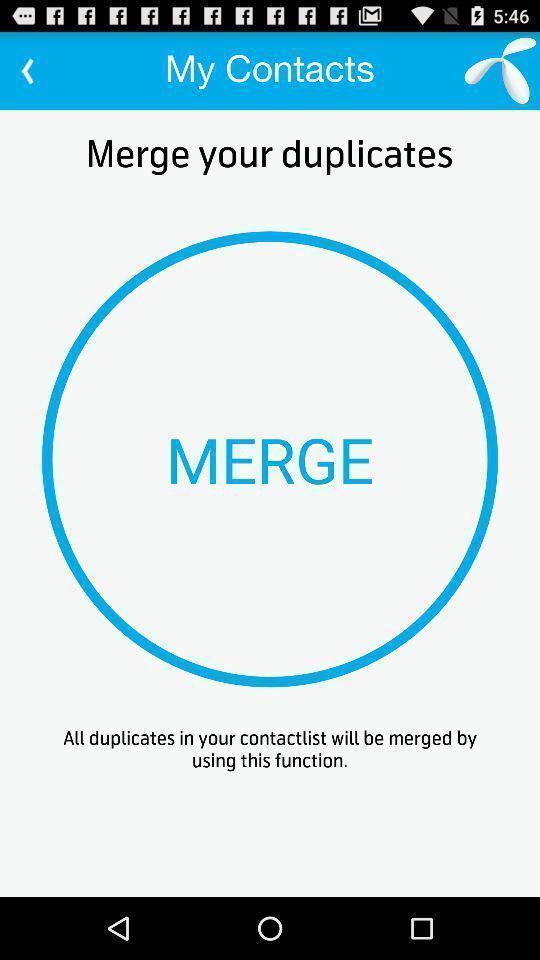What is the overall content of this screenshot? Page displays to merge contacts in app. 